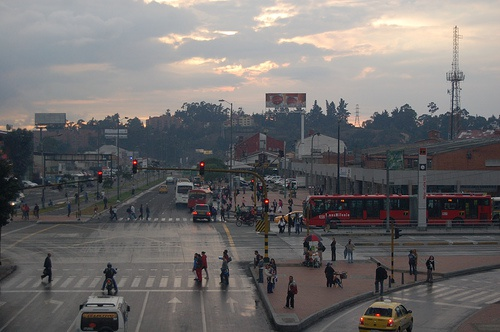Describe the objects in this image and their specific colors. I can see people in darkgray, black, gray, and maroon tones, bus in darkgray, black, maroon, gray, and brown tones, truck in darkgray, black, gray, and maroon tones, car in darkgray, black, gray, and maroon tones, and car in darkgray, black, olive, maroon, and gray tones in this image. 